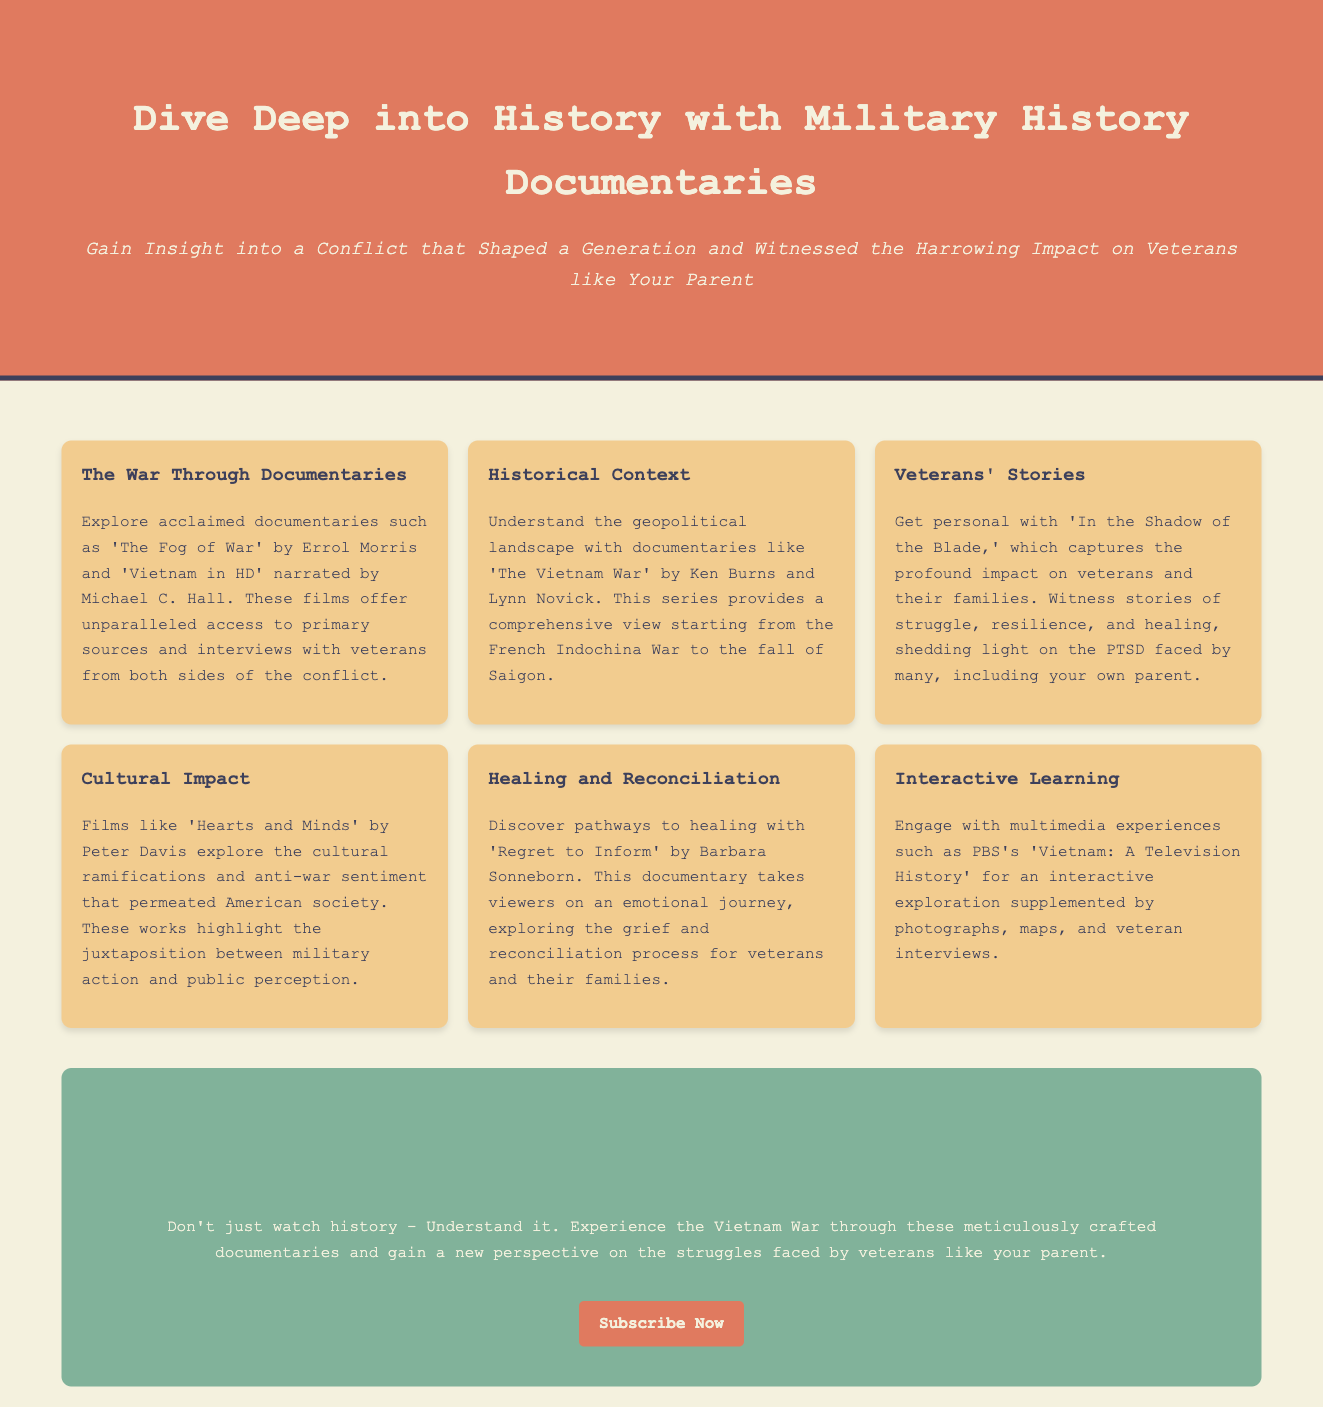What is the title of the advertisement? The title of the advertisement is prominently displayed in the header section.
Answer: Understanding the Vietnam War Who are the creators of the documentary "The Vietnam War"? The creators of the documentary are mentioned in the context of its historical significance.
Answer: Ken Burns and Lynn Novick What type of stories does "In the Shadow of the Blade" capture? The content item explains the focus of the documentary regarding personal experiences.
Answer: Veterans' stories Which film is directed by Errol Morris? The documentary list includes several titles and their directors.
Answer: The Fog of War What does the documentary "Regret to Inform" explore? The description under "Healing and Reconciliation" provides insight into the film's focus.
Answer: Grief and reconciliation What color is the background of the call-to-action section? The document specifies the visual design elements used.
Answer: #81b29a Which phrase highlights the emotional impact of the documentaries? The subheadline presents a poignant statement about the documentaries' relevance.
Answer: Gain Insight into a Conflict that Shaped a Generation and Witnessed the Harrowing Impact on Veterans like Your Parent How does the advertisement encourage engagement with history? The last paragraph in the call-to-action section states the intent of the presentation.
Answer: Don't just watch history - Understand it What kind of experiences does PBS's documentary provide? The interactive learning section outlines the nature of these experiences.
Answer: Multimedia experiences 